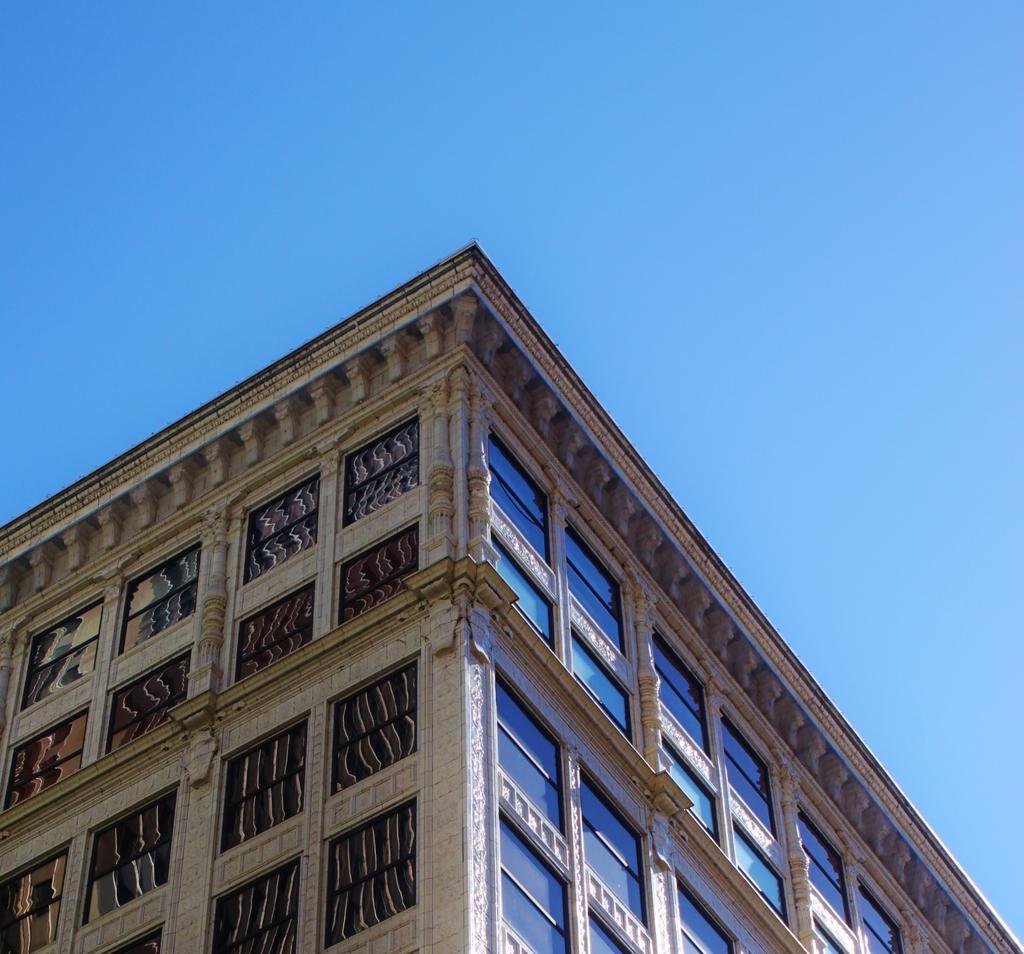Could you give a brief overview of what you see in this image? In the picture I can see a building which has windows. In the background I can see the sky. 